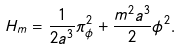Convert formula to latex. <formula><loc_0><loc_0><loc_500><loc_500>H _ { m } = \frac { 1 } { 2 a ^ { 3 } } \pi ^ { 2 } _ { \phi } + \frac { m ^ { 2 } a ^ { 3 } } { 2 } \phi ^ { 2 } .</formula> 